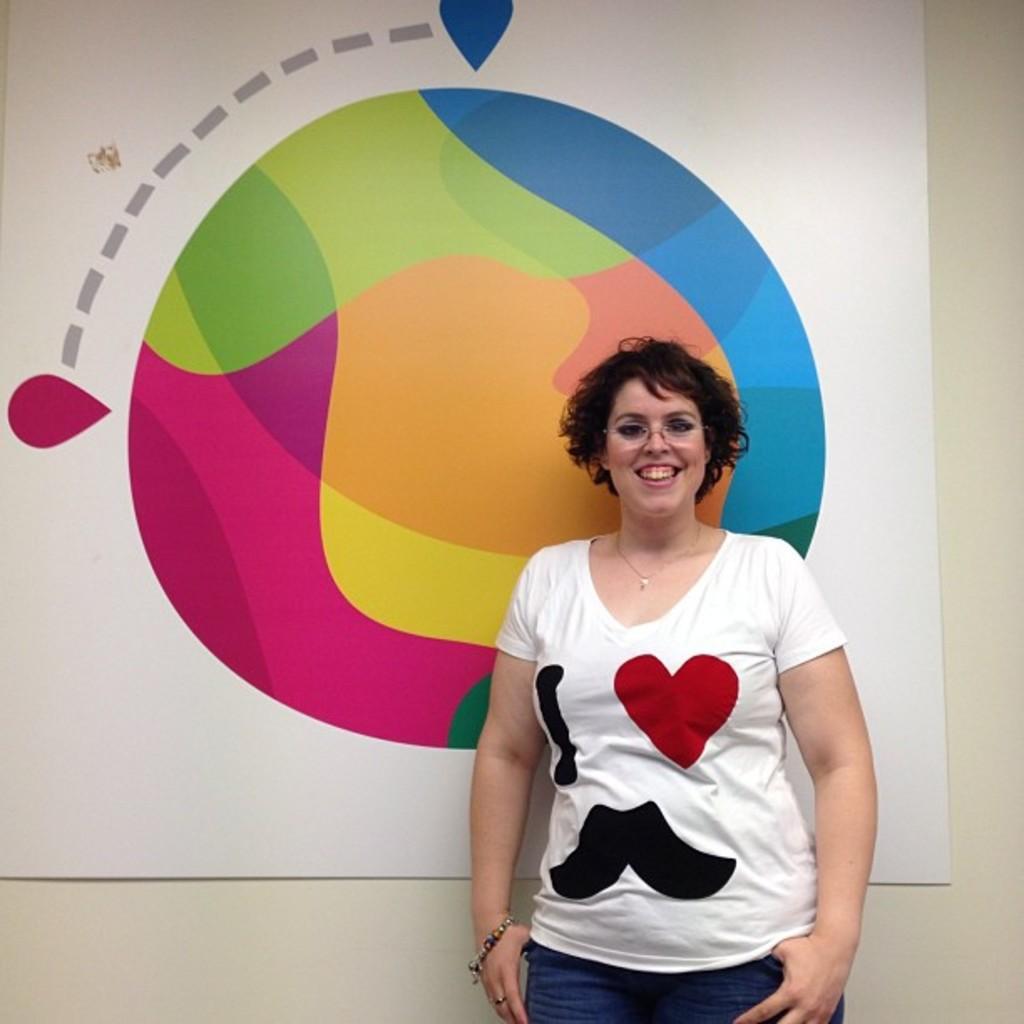Could you give a brief overview of what you see in this image? This picture seems to be clicked inside. In the center there is a woman wearing white color t-shirt, smiling and standing. In the background there is a banner hanging on the wall and we can see the picture of some object on the banner. 